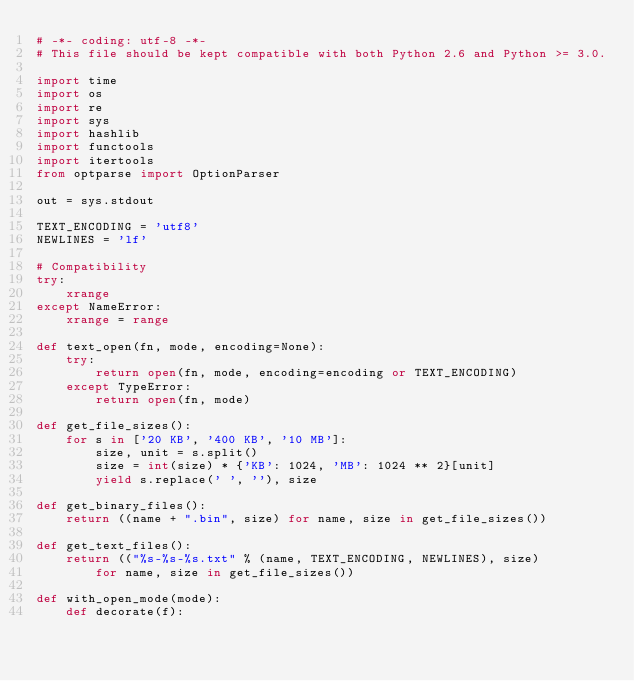<code> <loc_0><loc_0><loc_500><loc_500><_Python_># -*- coding: utf-8 -*-
# This file should be kept compatible with both Python 2.6 and Python >= 3.0.

import time
import os
import re
import sys
import hashlib
import functools
import itertools
from optparse import OptionParser

out = sys.stdout

TEXT_ENCODING = 'utf8'
NEWLINES = 'lf'

# Compatibility
try:
    xrange
except NameError:
    xrange = range

def text_open(fn, mode, encoding=None):
    try:
        return open(fn, mode, encoding=encoding or TEXT_ENCODING)
    except TypeError:
        return open(fn, mode)

def get_file_sizes():
    for s in ['20 KB', '400 KB', '10 MB']:
        size, unit = s.split()
        size = int(size) * {'KB': 1024, 'MB': 1024 ** 2}[unit]
        yield s.replace(' ', ''), size

def get_binary_files():
    return ((name + ".bin", size) for name, size in get_file_sizes())

def get_text_files():
    return (("%s-%s-%s.txt" % (name, TEXT_ENCODING, NEWLINES), size)
        for name, size in get_file_sizes())

def with_open_mode(mode):
    def decorate(f):</code> 